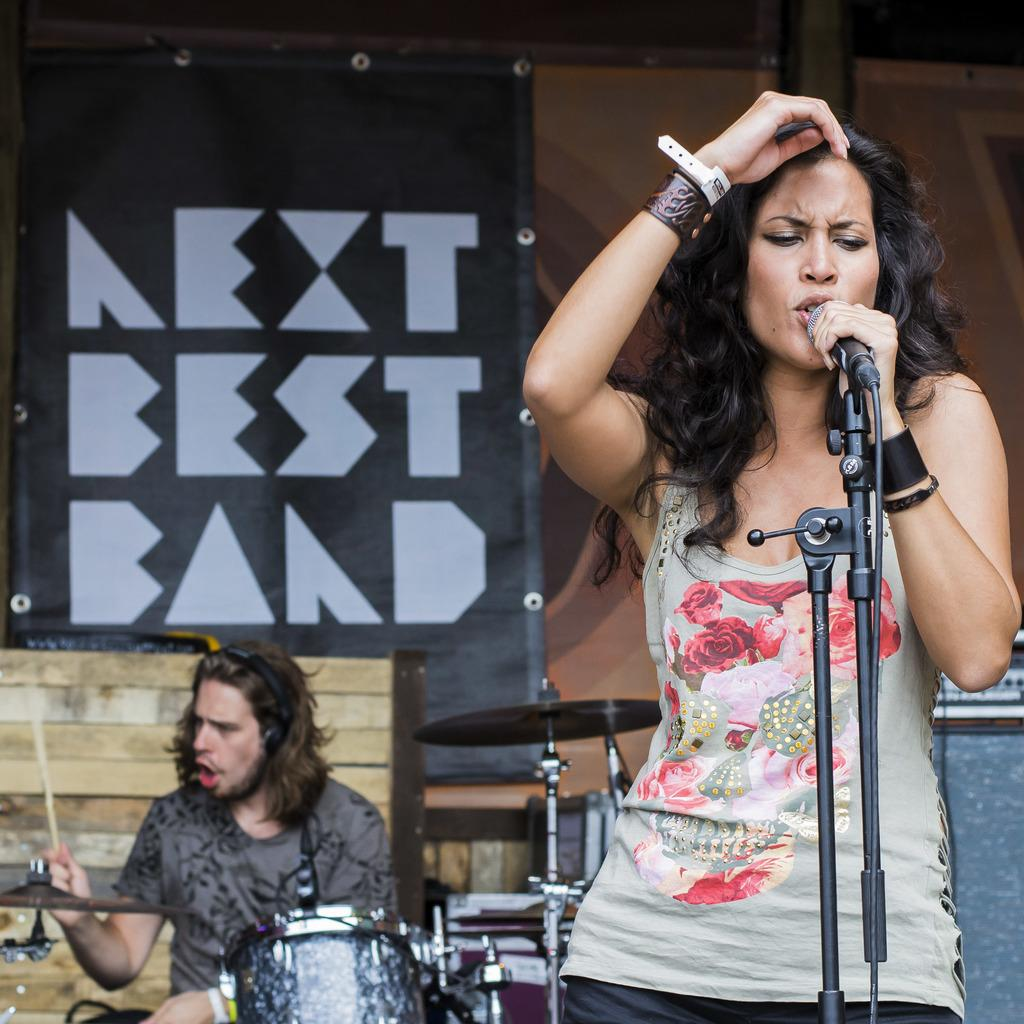What is the woman in the image doing? The woman is standing and singing, while holding a microphone. What is the man in the image doing? The man is sitting and playing drums. What can be seen in the background of the image? There is a wall and a board in the background of the image. What is the temper of the woman's friends in the image? There is no information about the temper or friends of the woman in the image. 